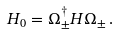<formula> <loc_0><loc_0><loc_500><loc_500>H _ { 0 } = \Omega _ { \pm } ^ { \dagger } H \Omega _ { \pm } \, .</formula> 